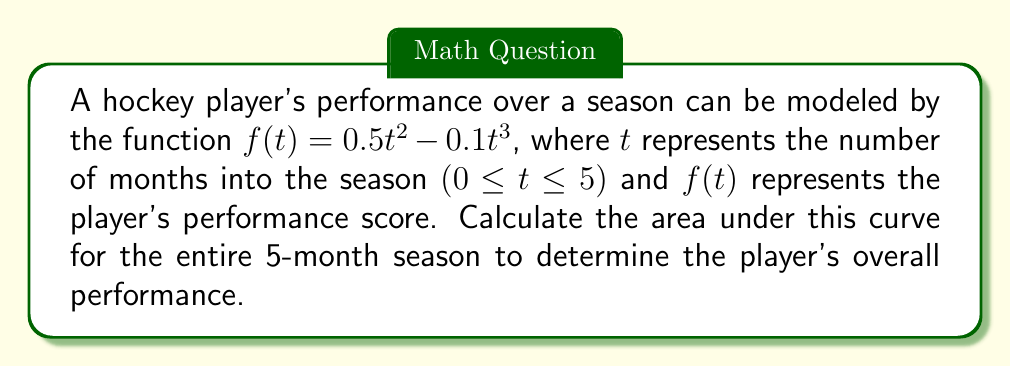Solve this math problem. To find the area under the curve, we need to integrate the function $f(t) = 0.5t^2 - 0.1t^3$ from $t = 0$ to $t = 5$. Let's follow these steps:

1) Set up the definite integral:
   $$\int_0^5 (0.5t^2 - 0.1t^3) dt$$

2) Integrate the function:
   $$\left[\frac{0.5t^3}{3} - \frac{0.1t^4}{4}\right]_0^5$$

3) Evaluate the integral at the upper and lower bounds:
   $$\left(\frac{0.5(5^3)}{3} - \frac{0.1(5^4)}{4}\right) - \left(\frac{0.5(0^3)}{3} - \frac{0.1(0^4)}{4}\right)$$

4) Simplify:
   $$\left(\frac{125}{6} - \frac{625}{8}\right) - (0 - 0)$$
   $$= \frac{125}{6} - \frac{625}{8}$$

5) Find a common denominator:
   $$= \frac{125 * 4}{24} - \frac{625 * 3}{24}$$
   $$= \frac{500 - 1875}{24}$$
   $$= \frac{-1375}{24}$$

6) Simplify the fraction:
   $$= -\frac{1375}{24} = -57.2916...$$

The negative result indicates that the area below the x-axis is larger than the area above it.
Answer: The area under the curve representing the player's performance over the 5-month season is approximately $-57.29$ units². 